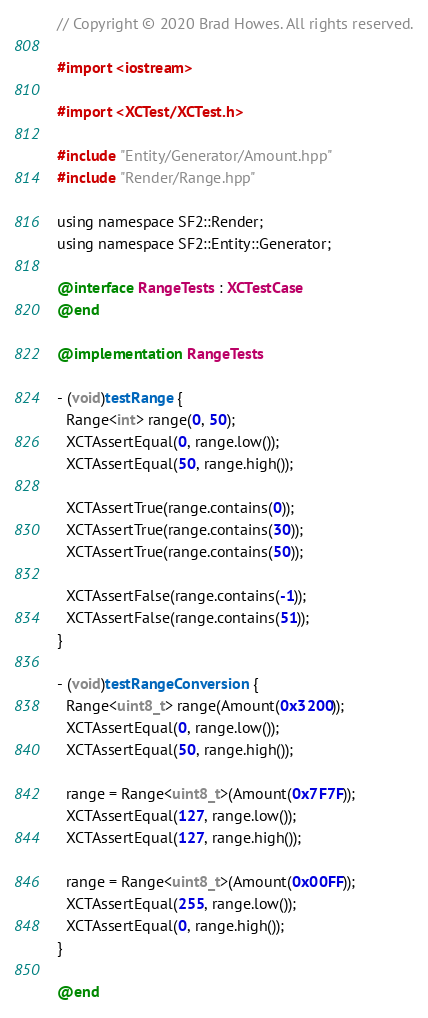<code> <loc_0><loc_0><loc_500><loc_500><_ObjectiveC_>// Copyright © 2020 Brad Howes. All rights reserved.

#import <iostream>

#import <XCTest/XCTest.h>

#include "Entity/Generator/Amount.hpp"
#include "Render/Range.hpp"

using namespace SF2::Render;
using namespace SF2::Entity::Generator;

@interface RangeTests : XCTestCase
@end

@implementation RangeTests

- (void)testRange {
  Range<int> range(0, 50);
  XCTAssertEqual(0, range.low());
  XCTAssertEqual(50, range.high());

  XCTAssertTrue(range.contains(0));
  XCTAssertTrue(range.contains(30));
  XCTAssertTrue(range.contains(50));

  XCTAssertFalse(range.contains(-1));
  XCTAssertFalse(range.contains(51));
}

- (void)testRangeConversion {
  Range<uint8_t> range(Amount(0x3200));
  XCTAssertEqual(0, range.low());
  XCTAssertEqual(50, range.high());

  range = Range<uint8_t>(Amount(0x7F7F));
  XCTAssertEqual(127, range.low());
  XCTAssertEqual(127, range.high());

  range = Range<uint8_t>(Amount(0x00FF));
  XCTAssertEqual(255, range.low());
  XCTAssertEqual(0, range.high());
}

@end
</code> 